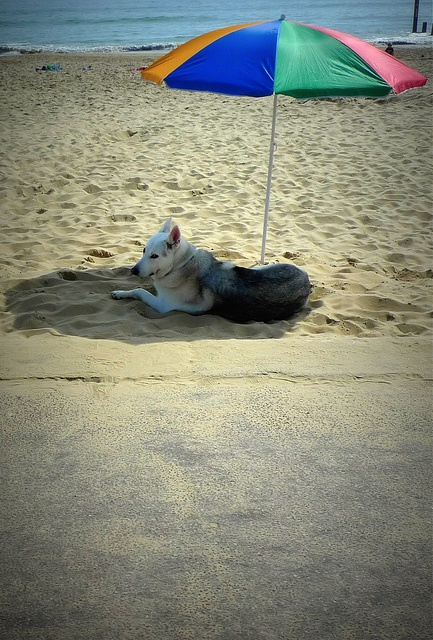Describe the objects in this image and their specific colors. I can see umbrella in blue, darkblue, and turquoise tones, dog in blue, black, gray, purple, and darkgray tones, and people in blue, black, gray, maroon, and navy tones in this image. 